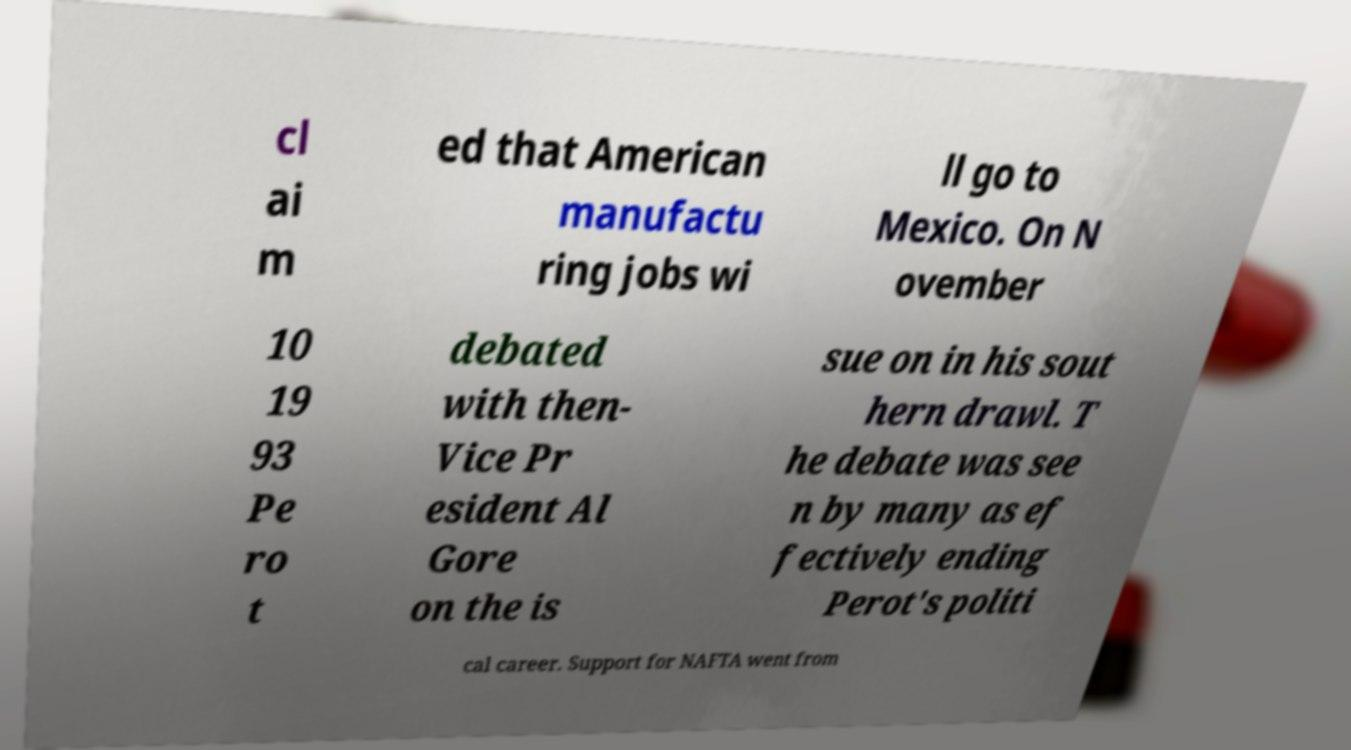Could you assist in decoding the text presented in this image and type it out clearly? cl ai m ed that American manufactu ring jobs wi ll go to Mexico. On N ovember 10 19 93 Pe ro t debated with then- Vice Pr esident Al Gore on the is sue on in his sout hern drawl. T he debate was see n by many as ef fectively ending Perot's politi cal career. Support for NAFTA went from 